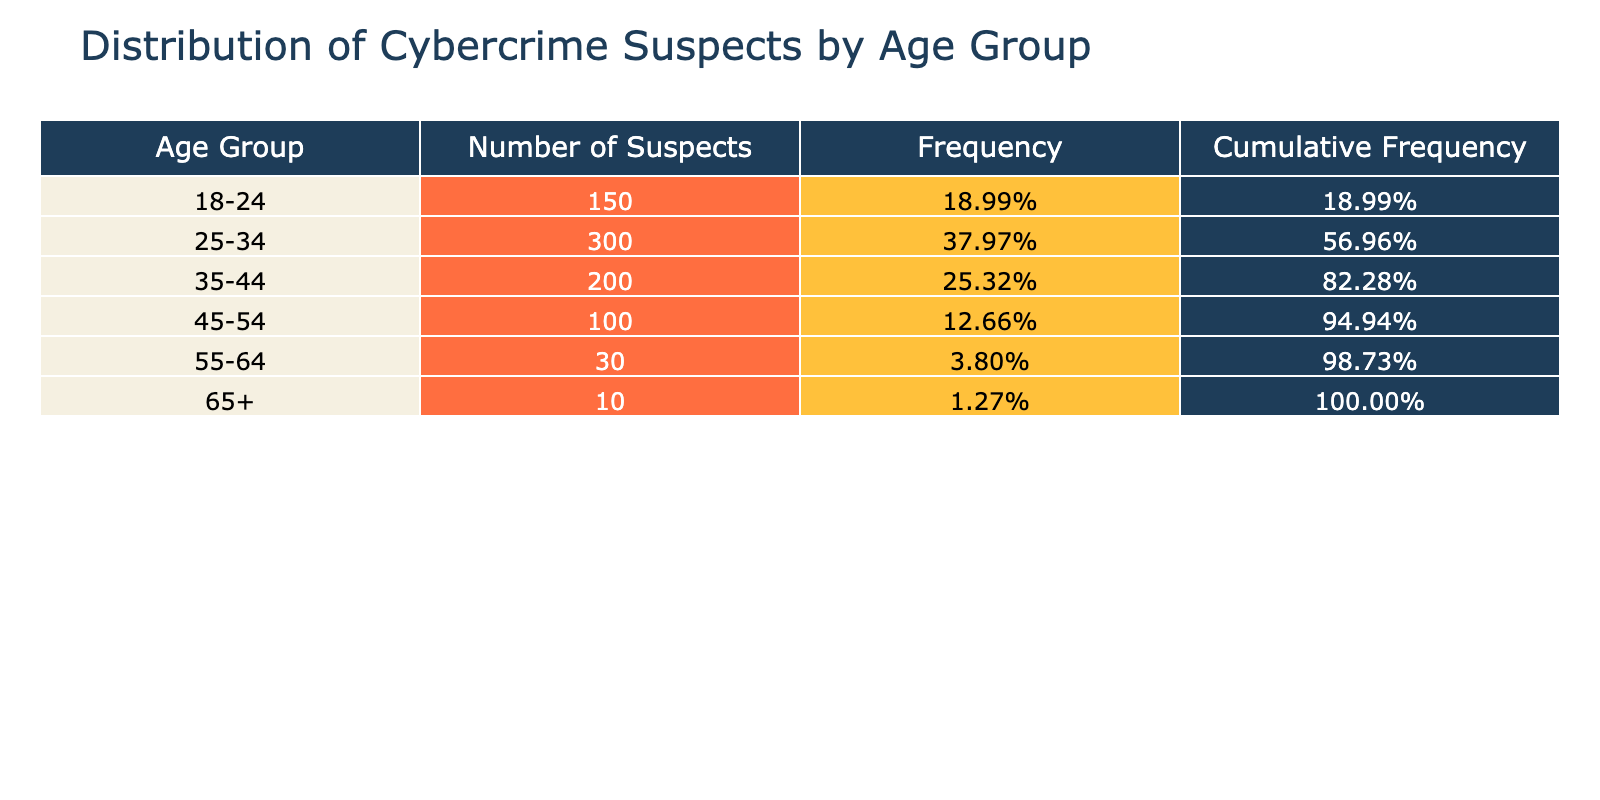What age group has the highest number of suspects? The table shows the number of suspects for each age group. The "25-34" age group has 300 suspects, which is the highest compared to other groups.
Answer: 25-34 What is the frequency of suspects in the 45-54 age group? The table provides the frequency of each age group. For the 45-54 age group, the number of suspects is 100. To find the frequency, divide by the total number of suspects (300 + 150 + 200 + 100 + 30 + 10 = 790). The frequency for this group is 100/790, which is approximately 0.1277.
Answer: 12.77% What age group has the least number of suspects? From the table, the “65+” age group has 10 suspects, which is the least when compared to other age groups.
Answer: 65+ Is the number of suspects in the 35-44 age group greater than the total number of suspects in the 55-64 and 65+ age groups combined? The number of suspects in the 35-44 age group is 200. For the 55-64 age group, there are 30 suspects, and in the 65+ age group, there are 10 suspects, giving a total of 30 + 10 = 40. Since 200 > 40, the statement is true.
Answer: Yes What is the cumulative frequency for the 25-34 age group? To find the cumulative frequency for the 25-34 age group, we add the frequencies of all preceding age groups. The frequencies are: 18-24 (150/790), 25-34 (300/790), which makes the cumulative frequency 150/790 + 300/790 = 450/790. Thus, the cumulative frequency for the 25-34 age group is approximately 0.5696.
Answer: 56.96% What is the combined total number of suspects in the age groups 18-24 and 45-54? To find the total number of suspects in the 18-24 and 45-54 age groups, we need to add their respective counts. The 18-24 group has 150 suspects and the 45-54 group has 100 suspects, resulting in 150 + 100 = 250 suspects.
Answer: 250 Is the frequency for the 55-64 age group less than 5%? The frequency for the 55-64 age group is calculated by dividing 30 by the total (790). This gives 30/790, which is approximately 0.0379. Since 0.0379 is less than 0.05, the statement is true.
Answer: Yes What percentage of suspects are aged 34 or older? To find this percentage, we need to sum the number of suspects in the age groups 35-44, 45-54, 55-64, and 65+. This totals 200 + 100 + 30 + 10 = 340. The total number of suspects is 790, so the percentage is (340/790) * 100, which is approximately 43.0%.
Answer: 43.0% How many suspects are there in the age group 55-64 compared to the total number of suspects under 35? The number of suspects in the 55-64 age group is 30. For suspects under 35, we sum the number from the 18-24 (150) and 25-34 (300) age groups, totaling 450. Comparing, 30 < 450, meaning there are fewer suspects in the 55-64 group.
Answer: Fewer 